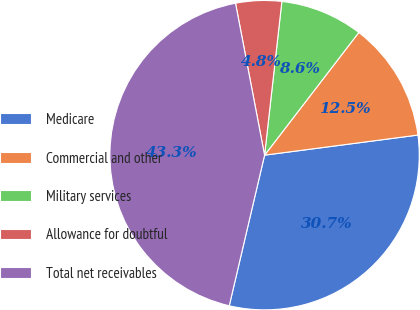Convert chart. <chart><loc_0><loc_0><loc_500><loc_500><pie_chart><fcel>Medicare<fcel>Commercial and other<fcel>Military services<fcel>Allowance for doubtful<fcel>Total net receivables<nl><fcel>30.74%<fcel>12.5%<fcel>8.64%<fcel>4.79%<fcel>43.32%<nl></chart> 